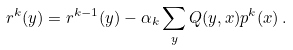<formula> <loc_0><loc_0><loc_500><loc_500>r ^ { k } ( y ) = r ^ { k - 1 } ( y ) - \alpha _ { k } \sum _ { y } Q ( y , x ) p ^ { k } ( x ) \, .</formula> 